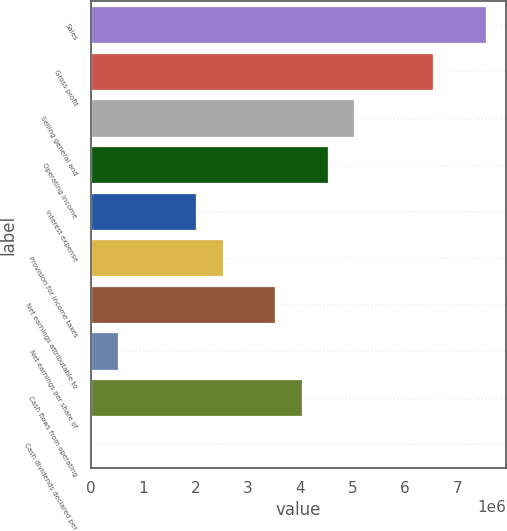Convert chart to OTSL. <chart><loc_0><loc_0><loc_500><loc_500><bar_chart><fcel>Sales<fcel>Gross profit<fcel>Selling general and<fcel>Operating income<fcel>Interest expense<fcel>Provision for income taxes<fcel>Net earnings attributable to<fcel>Net earnings per share of<fcel>Cash flows from operating<fcel>Cash dividends declared per<nl><fcel>7.5551e+06<fcel>6.54775e+06<fcel>5.03673e+06<fcel>4.53306e+06<fcel>2.01469e+06<fcel>2.51837e+06<fcel>3.52571e+06<fcel>503674<fcel>4.02939e+06<fcel>0.56<nl></chart> 